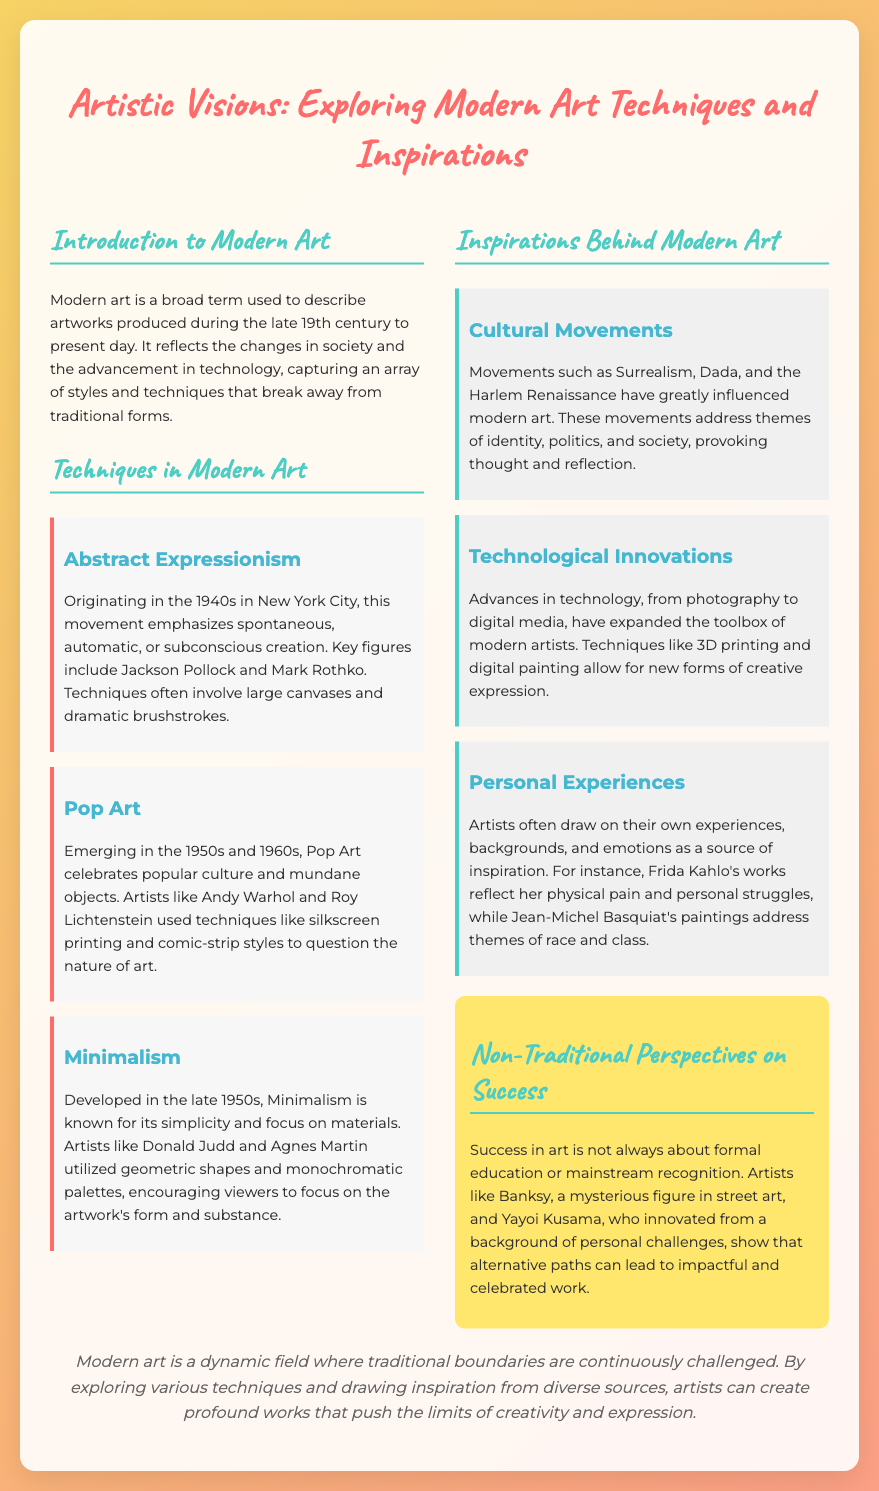what is the title of the presentation? The title of the presentation is stated at the beginning of the document.
Answer: Artistic Visions: Exploring Modern Art Techniques and Inspirations who are two key figures in Abstract Expressionism? The document mentions key figures in the Abstract Expressionism movement.
Answer: Jackson Pollock and Mark Rothko when did Pop Art emerge? The document specifies the time frame in which Pop Art emerged.
Answer: 1950s and 1960s what movement is known for its simplicity and geometric shapes? The document describes which movement emphasizes simplicity and geometric shapes.
Answer: Minimalism what are two influences on modern art mentioned in the document? The document lists various inspirations behind modern art.
Answer: Cultural Movements and Technological Innovations who is an artist noted for their personal struggles reflected in their work? The document provides an example of an artist whose work reflects personal experiences.
Answer: Frida Kahlo what is one technique used by Andy Warhol in his art? The document details specific techniques associated with the artist Andy Warhol.
Answer: Silkscreen printing how does the presentation define success in art? The document discusses alternative perspectives on how success is defined in art.
Answer: Not always about formal education or mainstream recognition what is the purpose of the "Non-Traditional Perspectives on Success" section? The document outlines the section's focus on alternative paths to achieving success in art.
Answer: To illustrate that alternative paths can lead to impactful and celebrated work 